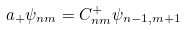Convert formula to latex. <formula><loc_0><loc_0><loc_500><loc_500>a _ { + } \psi _ { n m } = C _ { n m } ^ { + } \psi _ { n - 1 , m + 1 }</formula> 